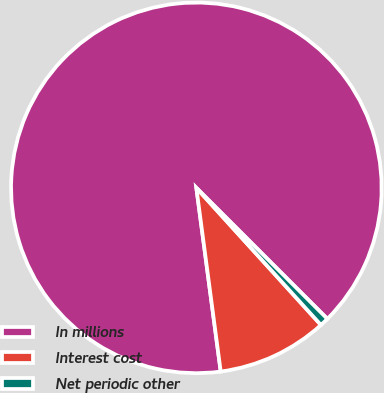Convert chart to OTSL. <chart><loc_0><loc_0><loc_500><loc_500><pie_chart><fcel>In millions<fcel>Interest cost<fcel>Net periodic other<nl><fcel>89.6%<fcel>9.64%<fcel>0.76%<nl></chart> 